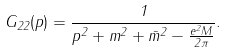Convert formula to latex. <formula><loc_0><loc_0><loc_500><loc_500>G _ { 2 2 } ( p ) = \frac { 1 } { p ^ { 2 } + m ^ { 2 } + \bar { m } ^ { 2 } - \frac { e ^ { 2 } M } { 2 \pi } } .</formula> 